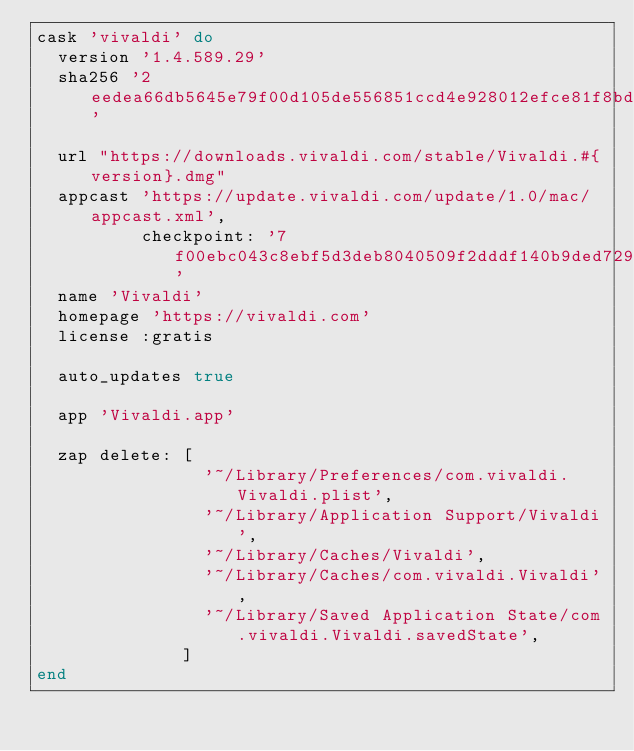<code> <loc_0><loc_0><loc_500><loc_500><_Ruby_>cask 'vivaldi' do
  version '1.4.589.29'
  sha256 '2eedea66db5645e79f00d105de556851ccd4e928012efce81f8bd9b5108ec9d6'

  url "https://downloads.vivaldi.com/stable/Vivaldi.#{version}.dmg"
  appcast 'https://update.vivaldi.com/update/1.0/mac/appcast.xml',
          checkpoint: '7f00ebc043c8ebf5d3deb8040509f2dddf140b9ded7299832b5100f0bd51b6be'
  name 'Vivaldi'
  homepage 'https://vivaldi.com'
  license :gratis

  auto_updates true

  app 'Vivaldi.app'

  zap delete: [
                '~/Library/Preferences/com.vivaldi.Vivaldi.plist',
                '~/Library/Application Support/Vivaldi',
                '~/Library/Caches/Vivaldi',
                '~/Library/Caches/com.vivaldi.Vivaldi',
                '~/Library/Saved Application State/com.vivaldi.Vivaldi.savedState',
              ]
end
</code> 